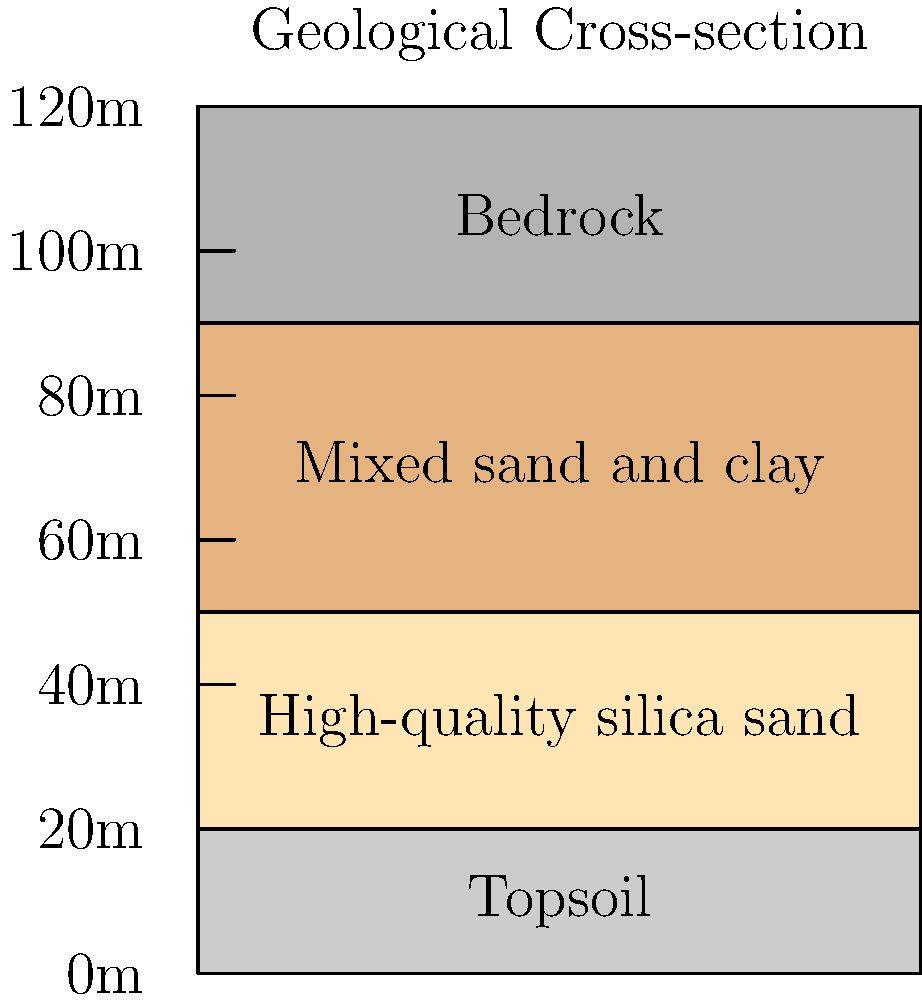Based on the geological cross-section diagram, at what depth range should the mining operation focus to extract the highest quality silica sand for glassblowing purposes? To determine the optimal mining depth for high-quality silica sand, we need to analyze the geological cross-section diagram:

1. The diagram shows four distinct layers from top to bottom:
   a) 0-20m: Topsoil
   b) 20-50m: High-quality silica sand
   c) 50-90m: Mixed sand and clay
   d) 90-120m: Bedrock

2. For glassblowing purposes, we need the purest form of silica sand, which is labeled as "High-quality silica sand" in the diagram.

3. The high-quality silica sand layer is located between 20m and 50m depth.

4. Mining above 20m would result in extracting topsoil, which is not suitable for glassblowing.

5. Mining below 50m would result in a mixture of sand and clay, which would require additional processing and reduce the overall quality of the extracted material.

6. Therefore, the optimal mining depth range for high-quality silica sand is between 20m and 50m.
Answer: 20-50m depth 